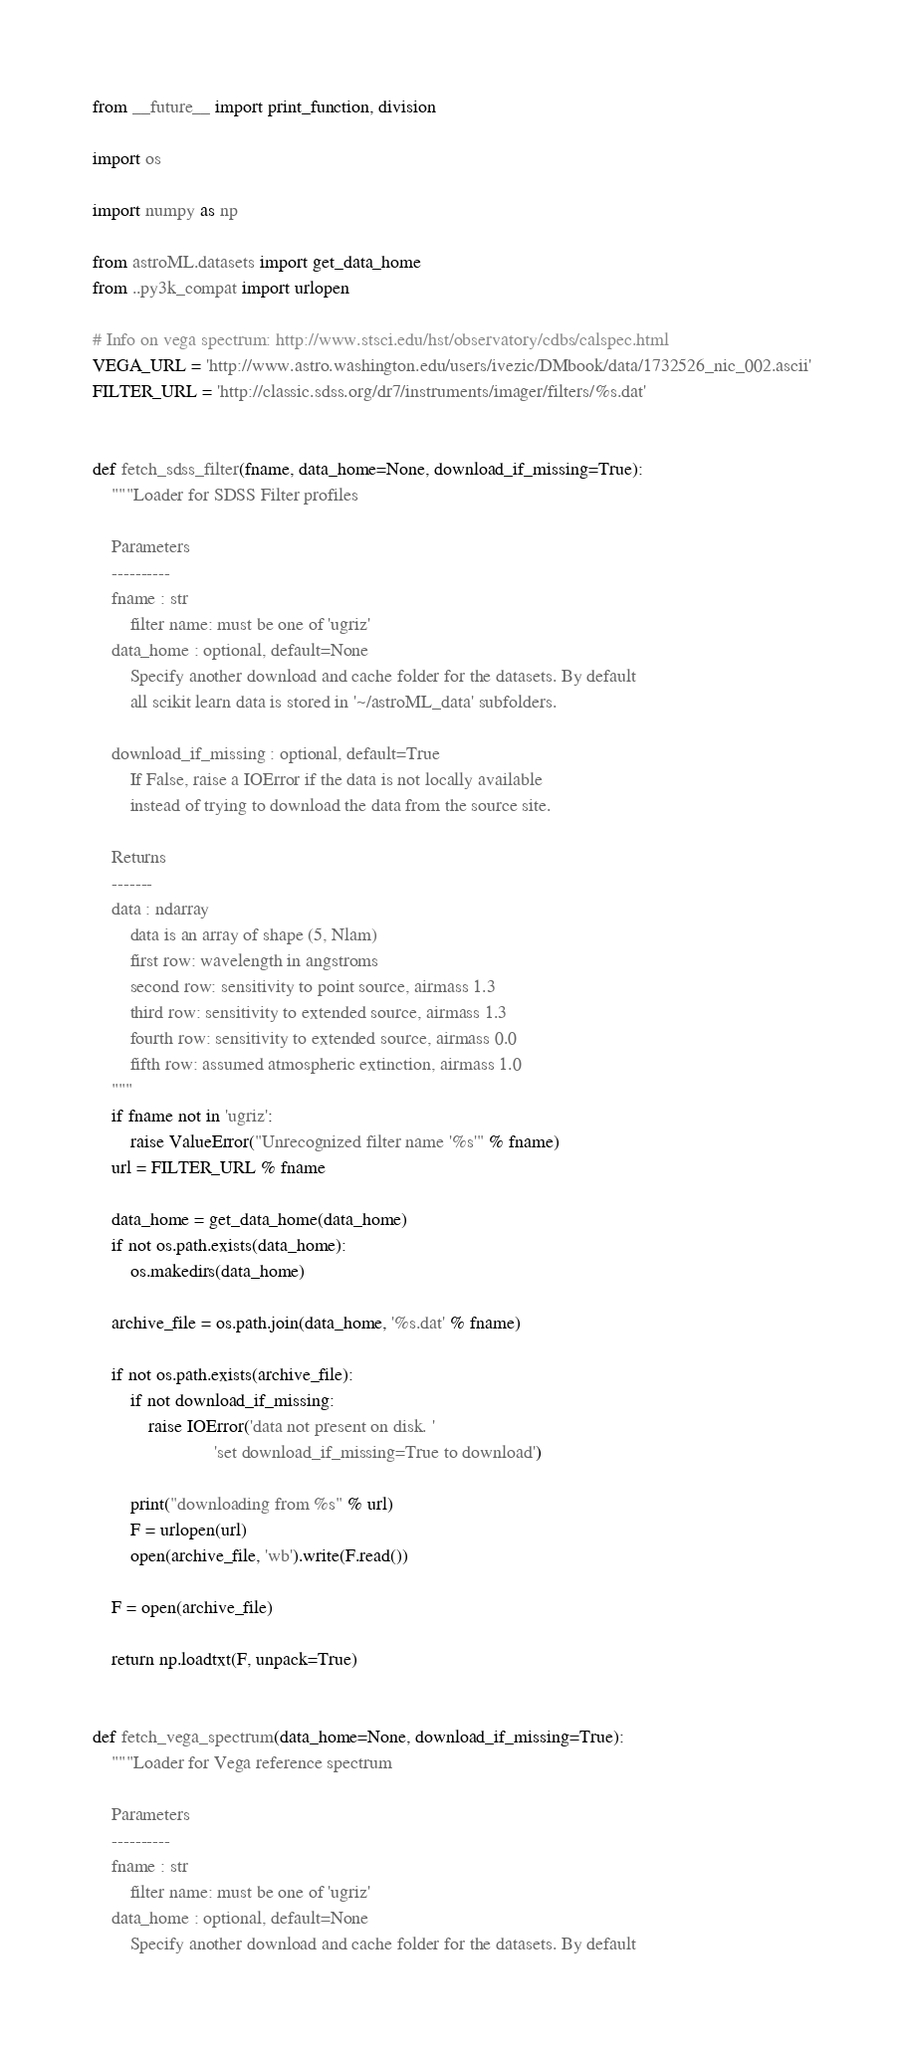<code> <loc_0><loc_0><loc_500><loc_500><_Python_>from __future__ import print_function, division

import os

import numpy as np

from astroML.datasets import get_data_home
from ..py3k_compat import urlopen

# Info on vega spectrum: http://www.stsci.edu/hst/observatory/cdbs/calspec.html
VEGA_URL = 'http://www.astro.washington.edu/users/ivezic/DMbook/data/1732526_nic_002.ascii'
FILTER_URL = 'http://classic.sdss.org/dr7/instruments/imager/filters/%s.dat'


def fetch_sdss_filter(fname, data_home=None, download_if_missing=True):
    """Loader for SDSS Filter profiles

    Parameters
    ----------
    fname : str
        filter name: must be one of 'ugriz'
    data_home : optional, default=None
        Specify another download and cache folder for the datasets. By default
        all scikit learn data is stored in '~/astroML_data' subfolders.

    download_if_missing : optional, default=True
        If False, raise a IOError if the data is not locally available
        instead of trying to download the data from the source site.

    Returns
    -------
    data : ndarray
        data is an array of shape (5, Nlam)
        first row: wavelength in angstroms
        second row: sensitivity to point source, airmass 1.3
        third row: sensitivity to extended source, airmass 1.3
        fourth row: sensitivity to extended source, airmass 0.0
        fifth row: assumed atmospheric extinction, airmass 1.0
    """
    if fname not in 'ugriz':
        raise ValueError("Unrecognized filter name '%s'" % fname)
    url = FILTER_URL % fname

    data_home = get_data_home(data_home)
    if not os.path.exists(data_home):
        os.makedirs(data_home)

    archive_file = os.path.join(data_home, '%s.dat' % fname)

    if not os.path.exists(archive_file):
        if not download_if_missing:
            raise IOError('data not present on disk. '
                          'set download_if_missing=True to download')

        print("downloading from %s" % url)
        F = urlopen(url)
        open(archive_file, 'wb').write(F.read())

    F = open(archive_file)

    return np.loadtxt(F, unpack=True)


def fetch_vega_spectrum(data_home=None, download_if_missing=True):
    """Loader for Vega reference spectrum

    Parameters
    ----------
    fname : str
        filter name: must be one of 'ugriz'
    data_home : optional, default=None
        Specify another download and cache folder for the datasets. By default</code> 